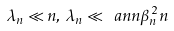Convert formula to latex. <formula><loc_0><loc_0><loc_500><loc_500>\lambda _ { n } \ll n , \, \lambda _ { n } \ll \ a n n \beta _ { n } ^ { 2 } n</formula> 